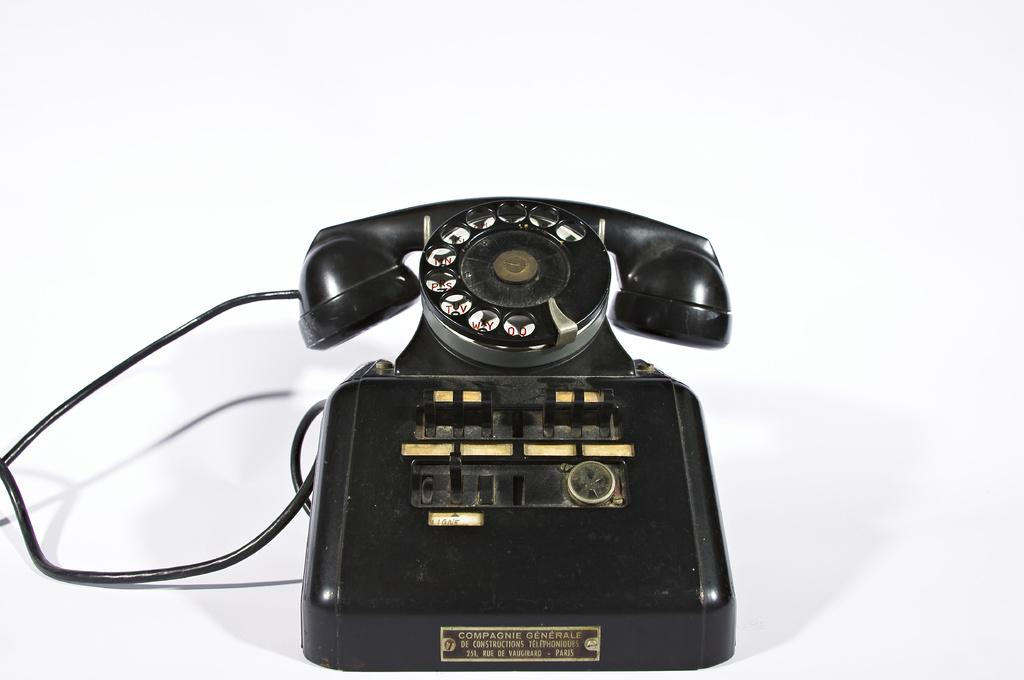What type of telephone is in the image? There is a black color telephone in the image. Is there any additional information attached to the telephone? Yes, the telephone has a tag with text attached to it. What is the color of the background in the image? The background of the image is white. Can you see a frog playing with the telephone in the image? No, there is no frog or any indication of playing in the image; it only features a black color telephone with a tag attached to it against a white background. 